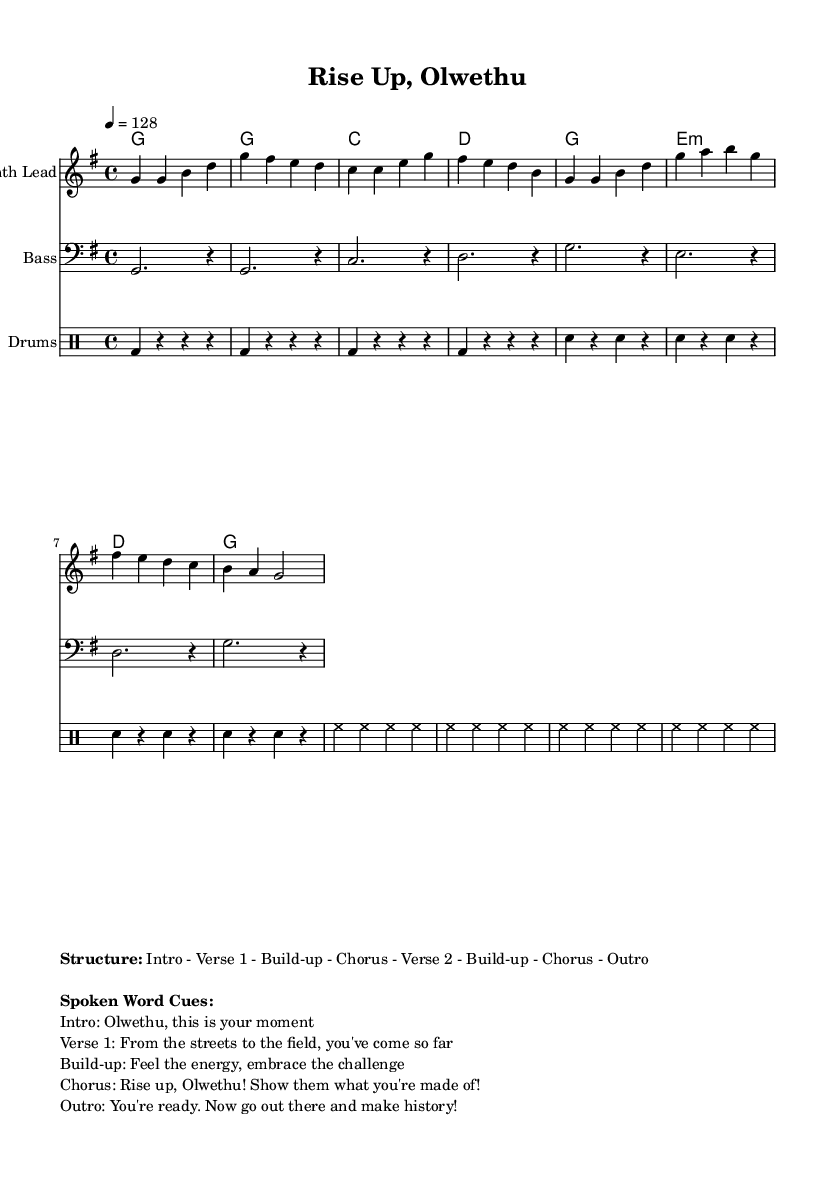What is the key signature of this music? The key signature is G major, which includes one sharp (F#). You can identify it by looking at the key signature indicated at the start of the staff, which shows one sharp.
Answer: G major What is the time signature of this music? The time signature is 4/4, meaning there are four beats per measure, and the quarter note gets one beat. This can be found at the beginning of the score where the time signature is displayed.
Answer: 4/4 What is the tempo marking of this music? The tempo marking is indicated as 128 beats per minute, meaning the piece should be played at a moderate tempo. This is shown after the key and time signature at the beginning of the score.
Answer: 128 How many sections are there in the structure of the piece? The structure includes eight sections: Intro, Verse 1, Build-up, Chorus, Verse 2, Build-up, Chorus, and Outro. This is detailed in the markup section at the end of the code where the structure is outlined.
Answer: 8 Which instrument plays the synth lead? The instrument labeled for the synth lead is the "Synth Lead." This can be found at the top of the respective staff in the score where the instrument name is specified.
Answer: Synth Lead What is the central message conveyed in the chorus section? The central message in the chorus is "Rise up, Olwethu! Show them what you're made of!" This can be inferred from the spoken word cues provided in the markup, specifically under the Chorus section.
Answer: "Rise up, Olwethu! Show them what you're made of!" 